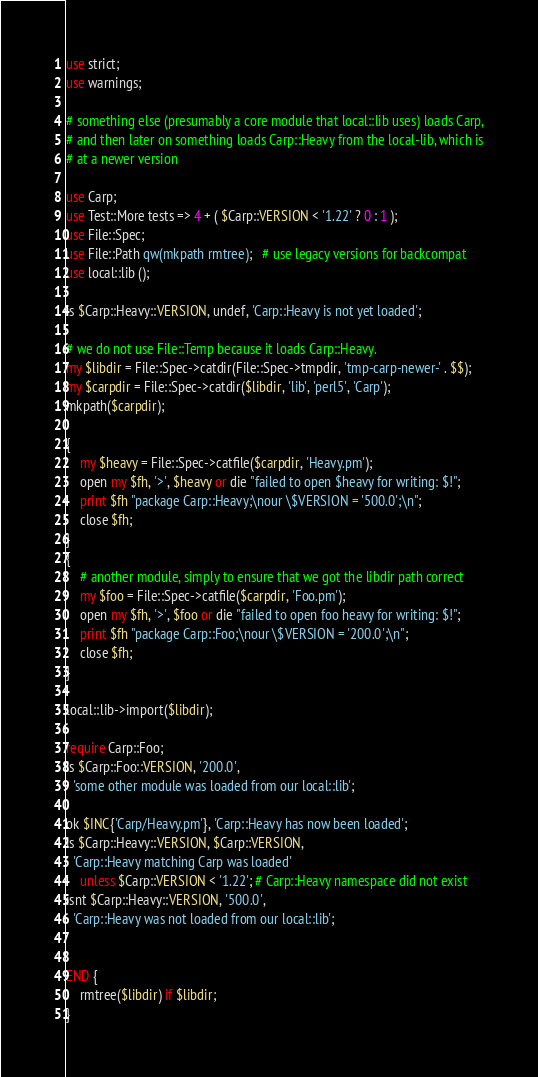Convert code to text. <code><loc_0><loc_0><loc_500><loc_500><_Perl_>use strict;
use warnings;

# something else (presumably a core module that local::lib uses) loads Carp,
# and then later on something loads Carp::Heavy from the local-lib, which is
# at a newer version

use Carp;
use Test::More tests => 4 + ( $Carp::VERSION < '1.22' ? 0 : 1 );
use File::Spec;
use File::Path qw(mkpath rmtree);   # use legacy versions for backcompat
use local::lib ();

is $Carp::Heavy::VERSION, undef, 'Carp::Heavy is not yet loaded';

# we do not use File::Temp because it loads Carp::Heavy.
my $libdir = File::Spec->catdir(File::Spec->tmpdir, 'tmp-carp-newer-' . $$);
my $carpdir = File::Spec->catdir($libdir, 'lib', 'perl5', 'Carp');
mkpath($carpdir);

{
    my $heavy = File::Spec->catfile($carpdir, 'Heavy.pm');
    open my $fh, '>', $heavy or die "failed to open $heavy for writing: $!";
    print $fh "package Carp::Heavy;\nour \$VERSION = '500.0';\n";
    close $fh;
}
{
    # another module, simply to ensure that we got the libdir path correct
    my $foo = File::Spec->catfile($carpdir, 'Foo.pm');
    open my $fh, '>', $foo or die "failed to open foo heavy for writing: $!";
    print $fh "package Carp::Foo;\nour \$VERSION = '200.0';\n";
    close $fh;
}

local::lib->import($libdir);

require Carp::Foo;
is $Carp::Foo::VERSION, '200.0',
  'some other module was loaded from our local::lib';

ok $INC{'Carp/Heavy.pm'}, 'Carp::Heavy has now been loaded';
is $Carp::Heavy::VERSION, $Carp::VERSION,
  'Carp::Heavy matching Carp was loaded'
    unless $Carp::VERSION < '1.22'; # Carp::Heavy namespace did not exist
isnt $Carp::Heavy::VERSION, '500.0',
  'Carp::Heavy was not loaded from our local::lib';


END {
    rmtree($libdir) if $libdir;
}
</code> 